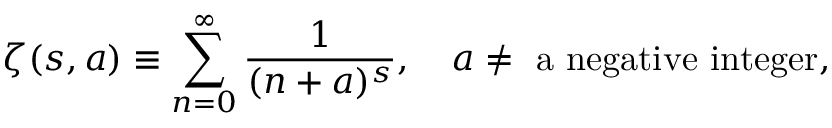Convert formula to latex. <formula><loc_0><loc_0><loc_500><loc_500>\zeta ( s , a ) \equiv \sum _ { n = 0 } ^ { \infty } \frac { 1 } { ( n + a ) ^ { s } } , \quad a \ne a n e g a t i v e i n t e g e r ,</formula> 